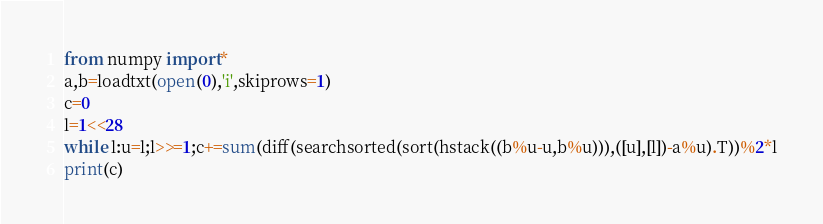<code> <loc_0><loc_0><loc_500><loc_500><_Python_>from numpy import*
a,b=loadtxt(open(0),'i',skiprows=1)
c=0
l=1<<28
while l:u=l;l>>=1;c+=sum(diff(searchsorted(sort(hstack((b%u-u,b%u))),([u],[l])-a%u).T))%2*l
print(c)</code> 